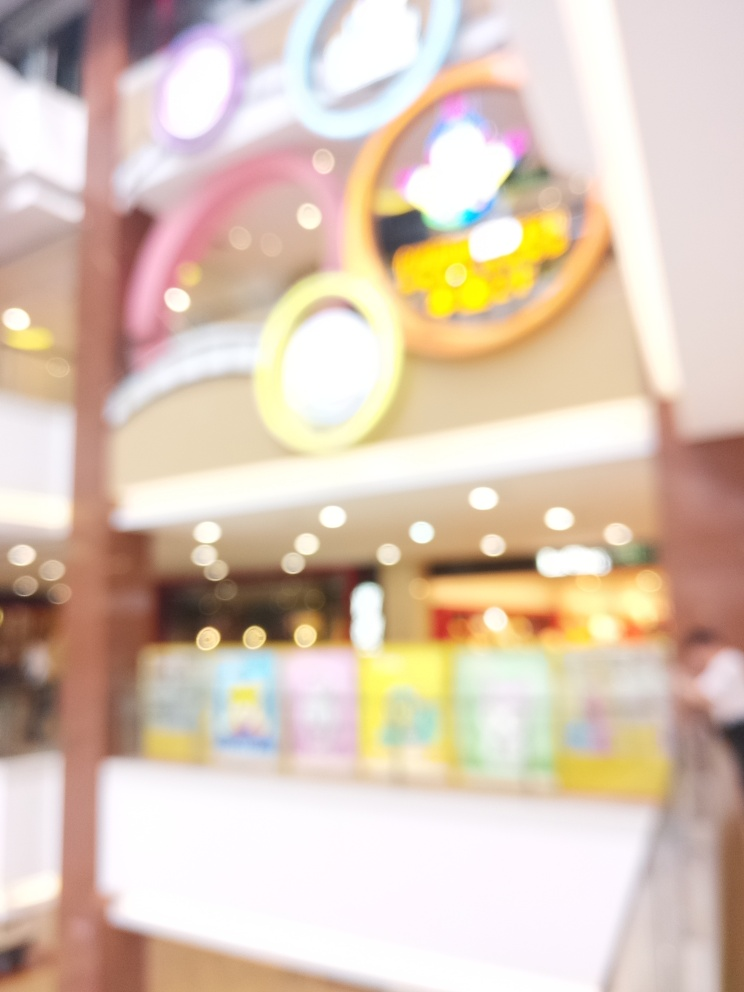Has the main subject lost most of its detailed textures? A. Yes B. No Answer with the option's letter from the given choices directly. Indeed, the main subject has lost most of its detailed textures. The photo shows significant blurring and loss of clarity, likely due to a focus issue or intentional artistic choice, making it difficult to discern fine details. Thus, the answer is A., Yes. 